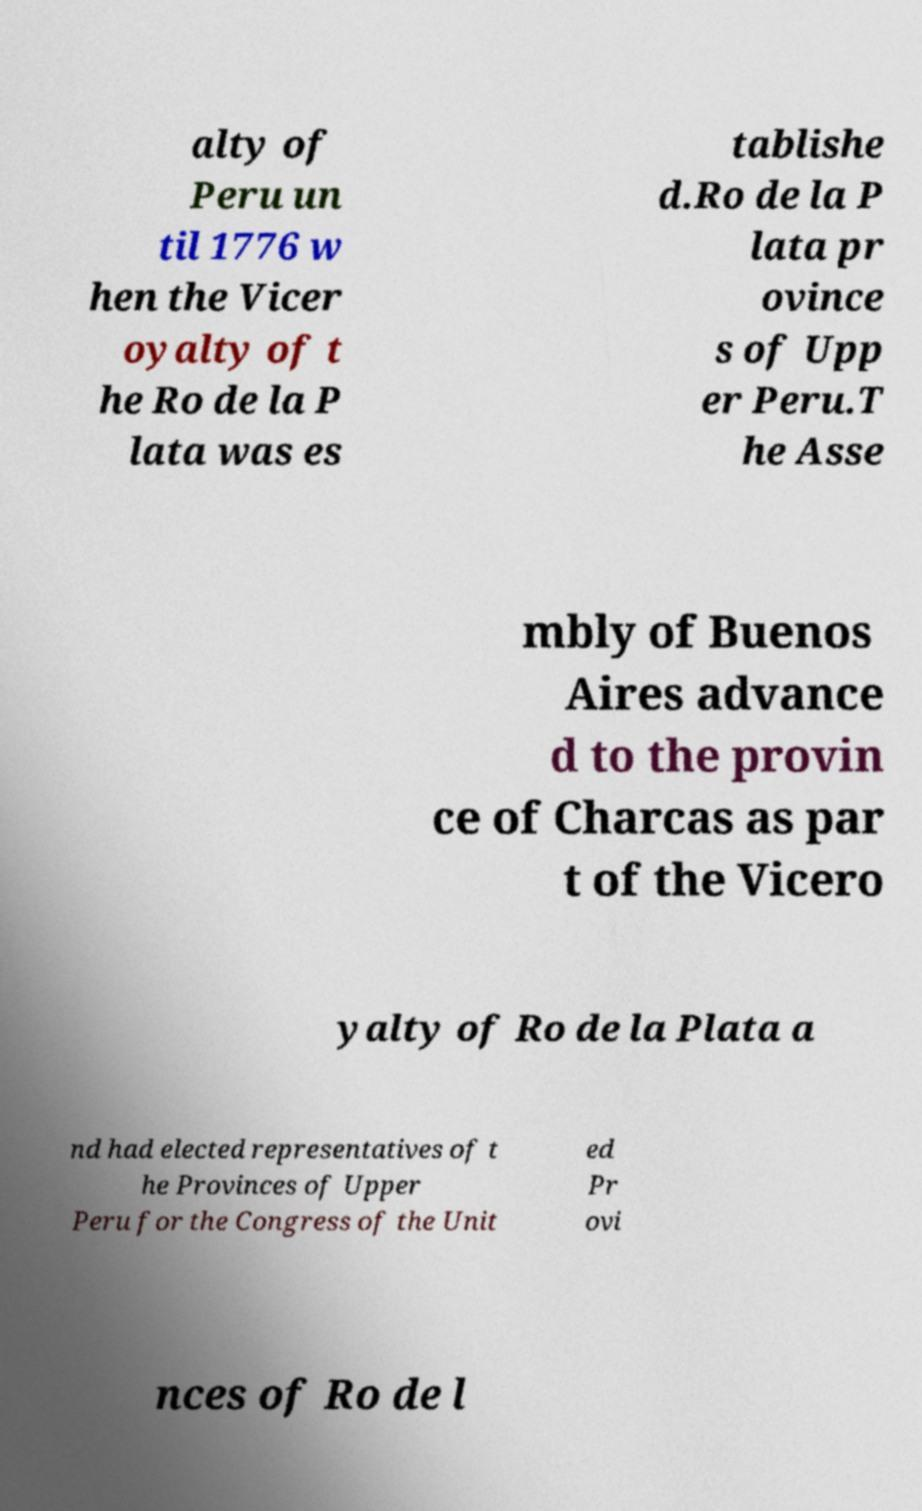Can you accurately transcribe the text from the provided image for me? alty of Peru un til 1776 w hen the Vicer oyalty of t he Ro de la P lata was es tablishe d.Ro de la P lata pr ovince s of Upp er Peru.T he Asse mbly of Buenos Aires advance d to the provin ce of Charcas as par t of the Vicero yalty of Ro de la Plata a nd had elected representatives of t he Provinces of Upper Peru for the Congress of the Unit ed Pr ovi nces of Ro de l 